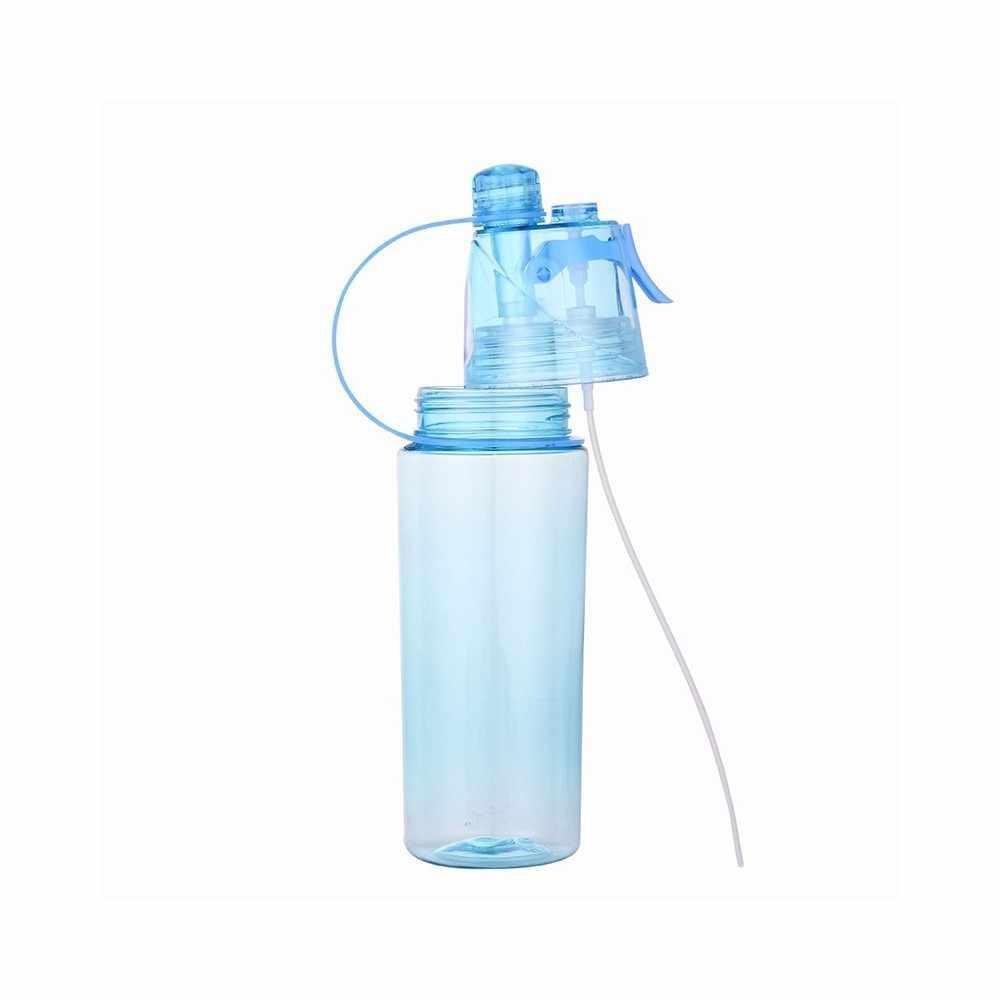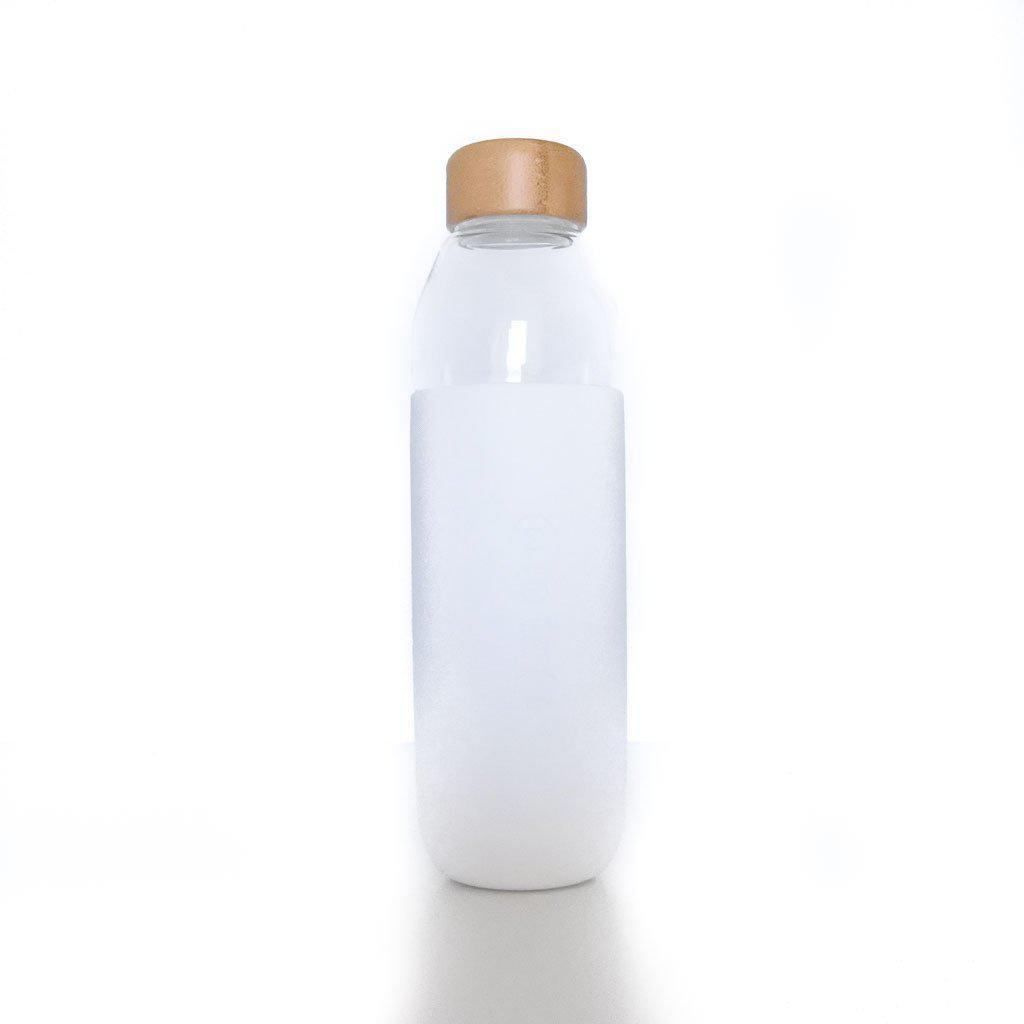The first image is the image on the left, the second image is the image on the right. For the images shown, is this caption "One of the bottles is closed and has a straw down the middle, a loop on the side, and a trigger on the opposite side." true? Answer yes or no. No. The first image is the image on the left, the second image is the image on the right. For the images shown, is this caption "There are exactly two bottles." true? Answer yes or no. Yes. 